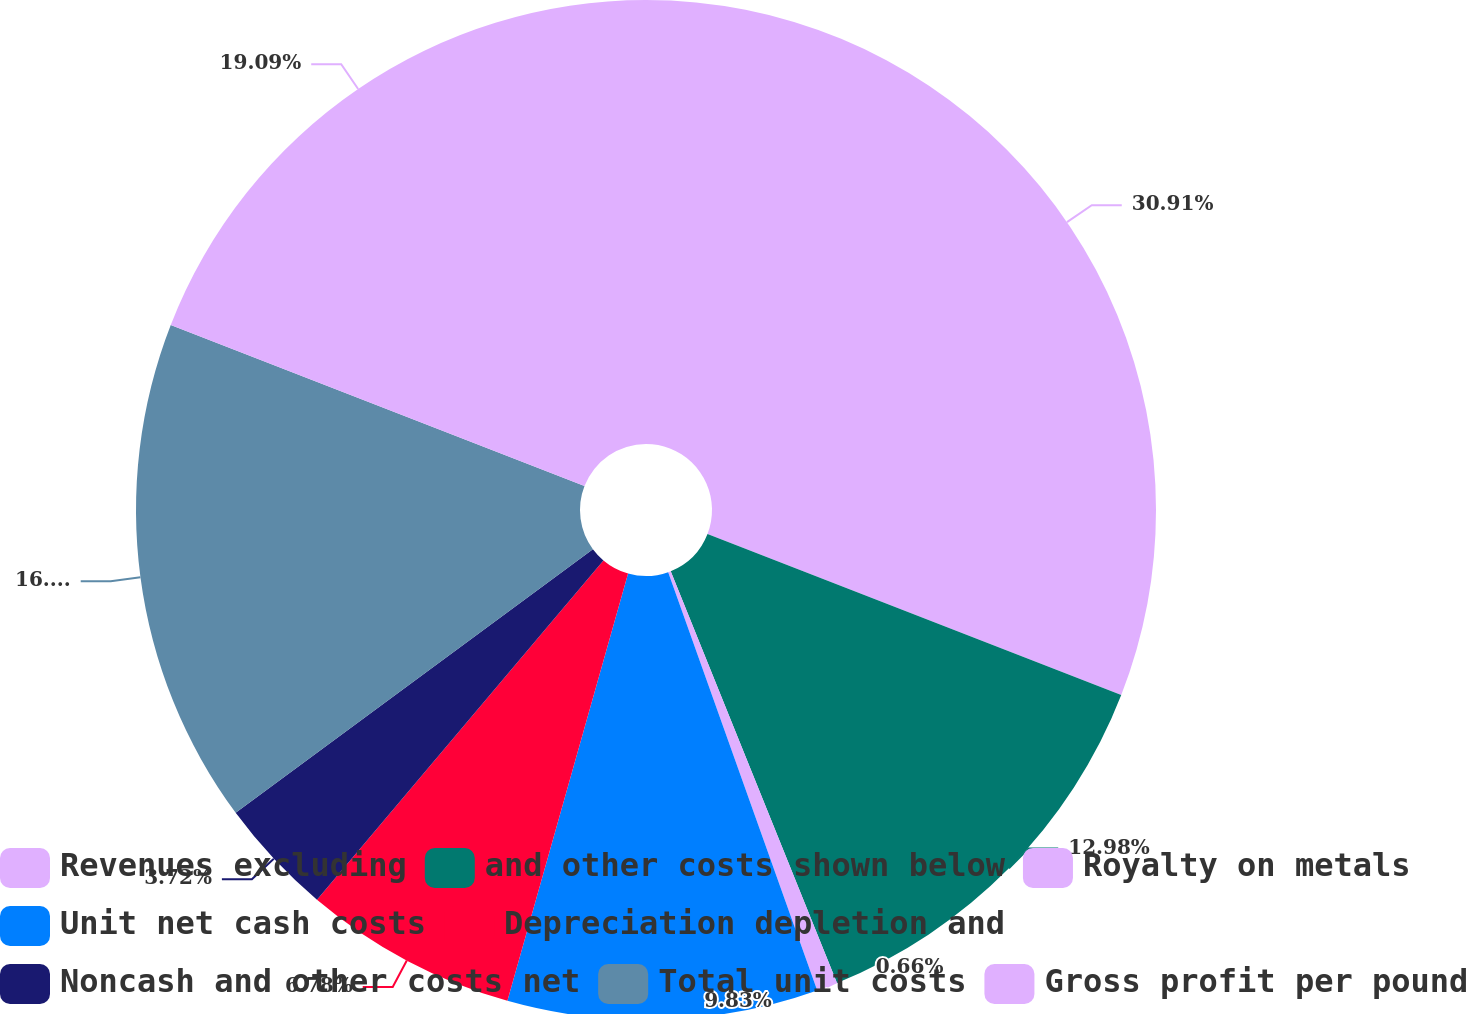<chart> <loc_0><loc_0><loc_500><loc_500><pie_chart><fcel>Revenues excluding<fcel>and other costs shown below<fcel>Royalty on metals<fcel>Unit net cash costs<fcel>Depreciation depletion and<fcel>Noncash and other costs net<fcel>Total unit costs<fcel>Gross profit per pound<nl><fcel>30.91%<fcel>12.98%<fcel>0.66%<fcel>9.83%<fcel>6.78%<fcel>3.72%<fcel>16.03%<fcel>19.09%<nl></chart> 